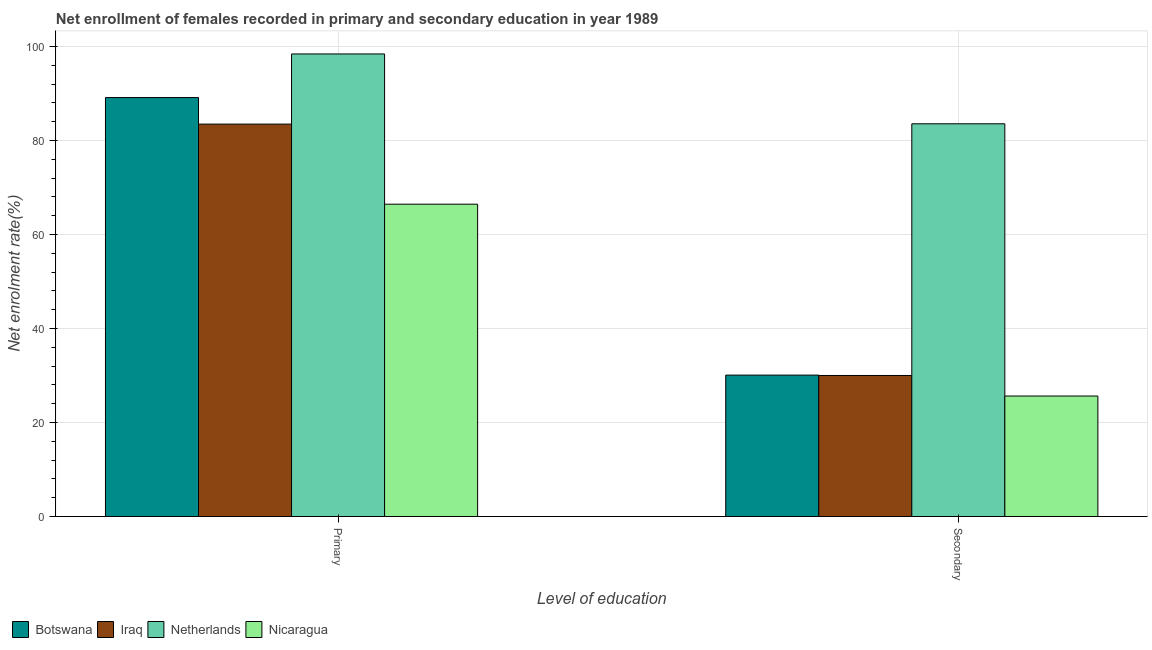Are the number of bars per tick equal to the number of legend labels?
Provide a short and direct response. Yes. Are the number of bars on each tick of the X-axis equal?
Offer a very short reply. Yes. How many bars are there on the 1st tick from the right?
Your response must be concise. 4. What is the label of the 1st group of bars from the left?
Your answer should be very brief. Primary. What is the enrollment rate in secondary education in Netherlands?
Keep it short and to the point. 83.58. Across all countries, what is the maximum enrollment rate in primary education?
Offer a terse response. 98.43. Across all countries, what is the minimum enrollment rate in secondary education?
Provide a short and direct response. 25.64. In which country was the enrollment rate in secondary education minimum?
Offer a terse response. Nicaragua. What is the total enrollment rate in primary education in the graph?
Your response must be concise. 337.56. What is the difference between the enrollment rate in primary education in Netherlands and that in Iraq?
Your answer should be very brief. 14.93. What is the difference between the enrollment rate in primary education in Botswana and the enrollment rate in secondary education in Netherlands?
Provide a short and direct response. 5.58. What is the average enrollment rate in primary education per country?
Offer a terse response. 84.39. What is the difference between the enrollment rate in secondary education and enrollment rate in primary education in Netherlands?
Offer a terse response. -14.86. What is the ratio of the enrollment rate in primary education in Netherlands to that in Botswana?
Offer a terse response. 1.1. Is the enrollment rate in primary education in Nicaragua less than that in Netherlands?
Your answer should be compact. Yes. What does the 1st bar from the right in Secondary represents?
Keep it short and to the point. Nicaragua. What is the difference between two consecutive major ticks on the Y-axis?
Offer a very short reply. 20. Are the values on the major ticks of Y-axis written in scientific E-notation?
Your answer should be compact. No. Does the graph contain grids?
Offer a terse response. Yes. How many legend labels are there?
Offer a terse response. 4. What is the title of the graph?
Offer a very short reply. Net enrollment of females recorded in primary and secondary education in year 1989. What is the label or title of the X-axis?
Give a very brief answer. Level of education. What is the label or title of the Y-axis?
Offer a terse response. Net enrolment rate(%). What is the Net enrolment rate(%) in Botswana in Primary?
Your answer should be compact. 89.15. What is the Net enrolment rate(%) in Iraq in Primary?
Provide a succinct answer. 83.51. What is the Net enrolment rate(%) in Netherlands in Primary?
Keep it short and to the point. 98.43. What is the Net enrolment rate(%) of Nicaragua in Primary?
Your answer should be very brief. 66.46. What is the Net enrolment rate(%) of Botswana in Secondary?
Offer a very short reply. 30.09. What is the Net enrolment rate(%) of Iraq in Secondary?
Ensure brevity in your answer.  30.02. What is the Net enrolment rate(%) in Netherlands in Secondary?
Your response must be concise. 83.58. What is the Net enrolment rate(%) of Nicaragua in Secondary?
Your answer should be compact. 25.64. Across all Level of education, what is the maximum Net enrolment rate(%) in Botswana?
Offer a terse response. 89.15. Across all Level of education, what is the maximum Net enrolment rate(%) in Iraq?
Your answer should be compact. 83.51. Across all Level of education, what is the maximum Net enrolment rate(%) in Netherlands?
Provide a succinct answer. 98.43. Across all Level of education, what is the maximum Net enrolment rate(%) of Nicaragua?
Your answer should be compact. 66.46. Across all Level of education, what is the minimum Net enrolment rate(%) of Botswana?
Provide a short and direct response. 30.09. Across all Level of education, what is the minimum Net enrolment rate(%) in Iraq?
Offer a very short reply. 30.02. Across all Level of education, what is the minimum Net enrolment rate(%) of Netherlands?
Your response must be concise. 83.58. Across all Level of education, what is the minimum Net enrolment rate(%) of Nicaragua?
Your answer should be compact. 25.64. What is the total Net enrolment rate(%) in Botswana in the graph?
Your answer should be very brief. 119.24. What is the total Net enrolment rate(%) in Iraq in the graph?
Make the answer very short. 113.52. What is the total Net enrolment rate(%) of Netherlands in the graph?
Your response must be concise. 182.01. What is the total Net enrolment rate(%) in Nicaragua in the graph?
Offer a very short reply. 92.1. What is the difference between the Net enrolment rate(%) of Botswana in Primary and that in Secondary?
Keep it short and to the point. 59.06. What is the difference between the Net enrolment rate(%) in Iraq in Primary and that in Secondary?
Your response must be concise. 53.49. What is the difference between the Net enrolment rate(%) of Netherlands in Primary and that in Secondary?
Keep it short and to the point. 14.86. What is the difference between the Net enrolment rate(%) in Nicaragua in Primary and that in Secondary?
Make the answer very short. 40.82. What is the difference between the Net enrolment rate(%) in Botswana in Primary and the Net enrolment rate(%) in Iraq in Secondary?
Offer a terse response. 59.14. What is the difference between the Net enrolment rate(%) of Botswana in Primary and the Net enrolment rate(%) of Netherlands in Secondary?
Provide a short and direct response. 5.58. What is the difference between the Net enrolment rate(%) of Botswana in Primary and the Net enrolment rate(%) of Nicaragua in Secondary?
Provide a succinct answer. 63.51. What is the difference between the Net enrolment rate(%) of Iraq in Primary and the Net enrolment rate(%) of Netherlands in Secondary?
Keep it short and to the point. -0.07. What is the difference between the Net enrolment rate(%) in Iraq in Primary and the Net enrolment rate(%) in Nicaragua in Secondary?
Offer a very short reply. 57.87. What is the difference between the Net enrolment rate(%) in Netherlands in Primary and the Net enrolment rate(%) in Nicaragua in Secondary?
Your answer should be very brief. 72.79. What is the average Net enrolment rate(%) of Botswana per Level of education?
Provide a short and direct response. 59.62. What is the average Net enrolment rate(%) in Iraq per Level of education?
Provide a short and direct response. 56.76. What is the average Net enrolment rate(%) in Netherlands per Level of education?
Keep it short and to the point. 91. What is the average Net enrolment rate(%) in Nicaragua per Level of education?
Keep it short and to the point. 46.05. What is the difference between the Net enrolment rate(%) in Botswana and Net enrolment rate(%) in Iraq in Primary?
Your answer should be very brief. 5.65. What is the difference between the Net enrolment rate(%) in Botswana and Net enrolment rate(%) in Netherlands in Primary?
Offer a terse response. -9.28. What is the difference between the Net enrolment rate(%) of Botswana and Net enrolment rate(%) of Nicaragua in Primary?
Your answer should be very brief. 22.69. What is the difference between the Net enrolment rate(%) of Iraq and Net enrolment rate(%) of Netherlands in Primary?
Your answer should be compact. -14.93. What is the difference between the Net enrolment rate(%) in Iraq and Net enrolment rate(%) in Nicaragua in Primary?
Give a very brief answer. 17.04. What is the difference between the Net enrolment rate(%) in Netherlands and Net enrolment rate(%) in Nicaragua in Primary?
Give a very brief answer. 31.97. What is the difference between the Net enrolment rate(%) in Botswana and Net enrolment rate(%) in Iraq in Secondary?
Ensure brevity in your answer.  0.08. What is the difference between the Net enrolment rate(%) in Botswana and Net enrolment rate(%) in Netherlands in Secondary?
Offer a terse response. -53.48. What is the difference between the Net enrolment rate(%) of Botswana and Net enrolment rate(%) of Nicaragua in Secondary?
Offer a terse response. 4.45. What is the difference between the Net enrolment rate(%) of Iraq and Net enrolment rate(%) of Netherlands in Secondary?
Offer a very short reply. -53.56. What is the difference between the Net enrolment rate(%) in Iraq and Net enrolment rate(%) in Nicaragua in Secondary?
Your response must be concise. 4.37. What is the difference between the Net enrolment rate(%) in Netherlands and Net enrolment rate(%) in Nicaragua in Secondary?
Provide a short and direct response. 57.93. What is the ratio of the Net enrolment rate(%) in Botswana in Primary to that in Secondary?
Offer a terse response. 2.96. What is the ratio of the Net enrolment rate(%) in Iraq in Primary to that in Secondary?
Ensure brevity in your answer.  2.78. What is the ratio of the Net enrolment rate(%) in Netherlands in Primary to that in Secondary?
Give a very brief answer. 1.18. What is the ratio of the Net enrolment rate(%) of Nicaragua in Primary to that in Secondary?
Keep it short and to the point. 2.59. What is the difference between the highest and the second highest Net enrolment rate(%) in Botswana?
Ensure brevity in your answer.  59.06. What is the difference between the highest and the second highest Net enrolment rate(%) in Iraq?
Provide a short and direct response. 53.49. What is the difference between the highest and the second highest Net enrolment rate(%) of Netherlands?
Your answer should be very brief. 14.86. What is the difference between the highest and the second highest Net enrolment rate(%) in Nicaragua?
Offer a terse response. 40.82. What is the difference between the highest and the lowest Net enrolment rate(%) in Botswana?
Your answer should be compact. 59.06. What is the difference between the highest and the lowest Net enrolment rate(%) of Iraq?
Your response must be concise. 53.49. What is the difference between the highest and the lowest Net enrolment rate(%) of Netherlands?
Ensure brevity in your answer.  14.86. What is the difference between the highest and the lowest Net enrolment rate(%) in Nicaragua?
Keep it short and to the point. 40.82. 